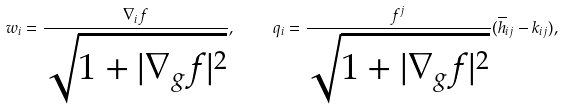Convert formula to latex. <formula><loc_0><loc_0><loc_500><loc_500>w _ { i } = \frac { \nabla _ { i } f } { \sqrt { 1 + | \nabla _ { g } f | ^ { 2 } } } , \text { } \text { } \text { } \text { } q _ { i } = \frac { f ^ { j } } { \sqrt { 1 + | \nabla _ { g } f | ^ { 2 } } } ( \overline { h } _ { i j } - k _ { i j } ) ,</formula> 